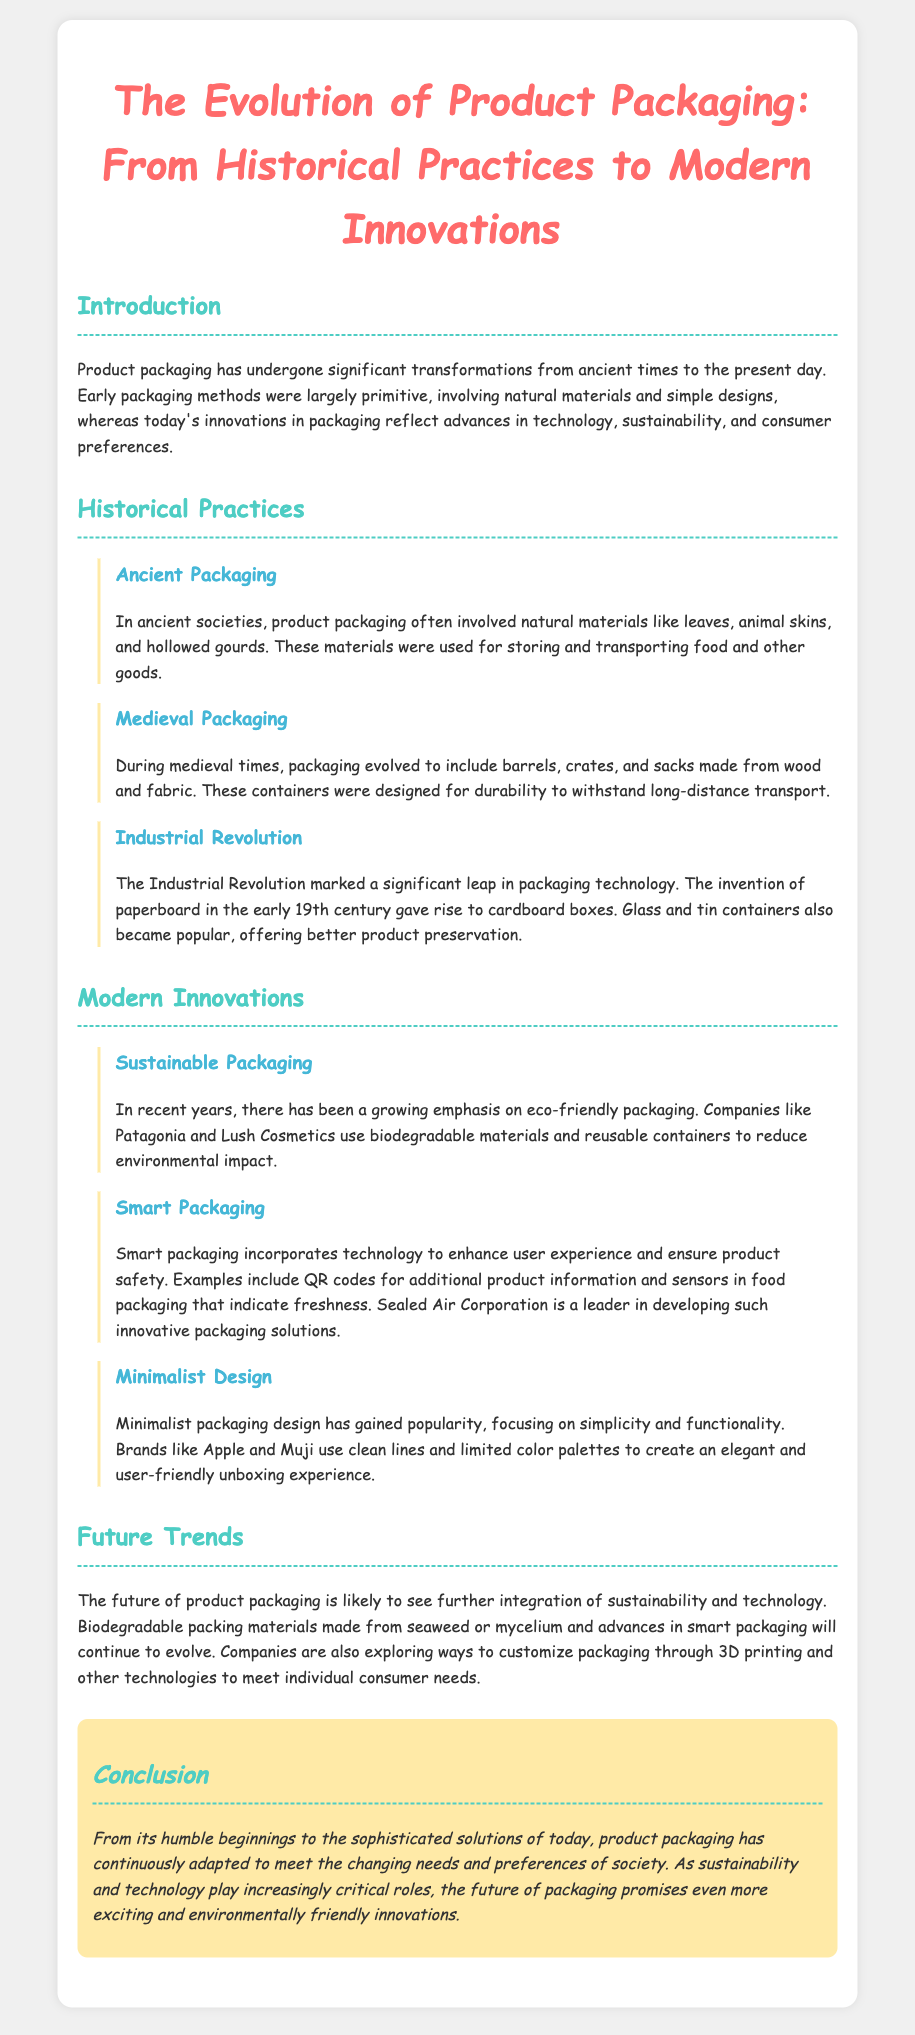What is the main focus of the document? The document discusses the evolution of product packaging from its historical practices to modern innovations.
Answer: The evolution of product packaging What materials were used for packaging in ancient societies? Ancient packaging often involved natural materials such as leaves, animal skins, and hollowed gourds.
Answer: Leaves, animal skins, and hollowed gourds What significant change occurred during the Industrial Revolution? The Industrial Revolution saw the invention of paperboard leading to the rise of cardboard boxes.
Answer: Invention of paperboard Which companies are noted for using sustainable packaging? Companies like Patagonia and Lush Cosmetics are mentioned for their use of biodegradable materials and reusable containers.
Answer: Patagonia and Lush Cosmetics What does smart packaging often include? Smart packaging incorporates technology like QR codes and sensors that indicate freshness.
Answer: QR codes and sensors What is a major trend expected in the future of product packaging? The document indicates that the future will see more integration of sustainability and technology.
Answer: Integration of sustainability and technology What type of design has gained popularity, as mentioned in the document? Minimalist design, focusing on simplicity and functionality, has gained popularity.
Answer: Minimalist design Which sector is Sealed Air Corporation a leader in? Sealed Air Corporation is noted as a leader in developing innovative packaging solutions.
Answer: Innovative packaging solutions What does the conclusion suggest about the future of packaging? The conclusion mentions promising developments, particularly concerning sustainability and technology.
Answer: Sustainability and technology 